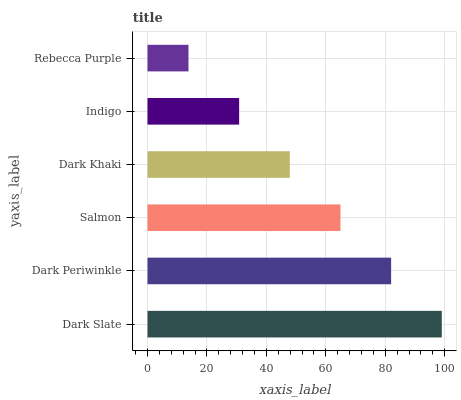Is Rebecca Purple the minimum?
Answer yes or no. Yes. Is Dark Slate the maximum?
Answer yes or no. Yes. Is Dark Periwinkle the minimum?
Answer yes or no. No. Is Dark Periwinkle the maximum?
Answer yes or no. No. Is Dark Slate greater than Dark Periwinkle?
Answer yes or no. Yes. Is Dark Periwinkle less than Dark Slate?
Answer yes or no. Yes. Is Dark Periwinkle greater than Dark Slate?
Answer yes or no. No. Is Dark Slate less than Dark Periwinkle?
Answer yes or no. No. Is Salmon the high median?
Answer yes or no. Yes. Is Dark Khaki the low median?
Answer yes or no. Yes. Is Indigo the high median?
Answer yes or no. No. Is Rebecca Purple the low median?
Answer yes or no. No. 